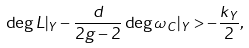Convert formula to latex. <formula><loc_0><loc_0><loc_500><loc_500>\deg L | _ { Y } - \frac { d } { 2 g - 2 } \deg \omega _ { C } | _ { Y } > - \frac { k _ { Y } } { 2 } ,</formula> 